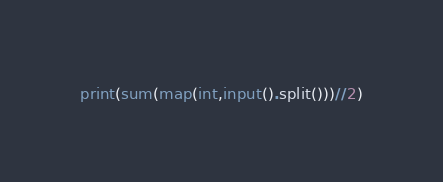<code> <loc_0><loc_0><loc_500><loc_500><_Python_>print(sum(map(int,input().split()))//2)</code> 